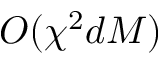Convert formula to latex. <formula><loc_0><loc_0><loc_500><loc_500>O ( \chi ^ { 2 } d M )</formula> 